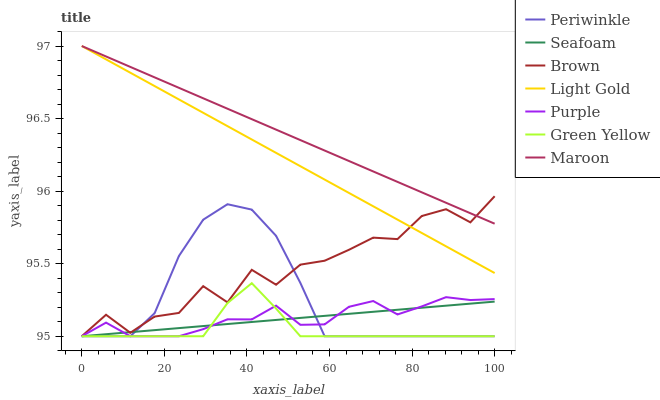Does Green Yellow have the minimum area under the curve?
Answer yes or no. Yes. Does Maroon have the maximum area under the curve?
Answer yes or no. Yes. Does Purple have the minimum area under the curve?
Answer yes or no. No. Does Purple have the maximum area under the curve?
Answer yes or no. No. Is Maroon the smoothest?
Answer yes or no. Yes. Is Brown the roughest?
Answer yes or no. Yes. Is Purple the smoothest?
Answer yes or no. No. Is Purple the roughest?
Answer yes or no. No. Does Brown have the lowest value?
Answer yes or no. Yes. Does Maroon have the lowest value?
Answer yes or no. No. Does Light Gold have the highest value?
Answer yes or no. Yes. Does Purple have the highest value?
Answer yes or no. No. Is Green Yellow less than Maroon?
Answer yes or no. Yes. Is Light Gold greater than Purple?
Answer yes or no. Yes. Does Green Yellow intersect Seafoam?
Answer yes or no. Yes. Is Green Yellow less than Seafoam?
Answer yes or no. No. Is Green Yellow greater than Seafoam?
Answer yes or no. No. Does Green Yellow intersect Maroon?
Answer yes or no. No. 